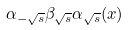<formula> <loc_0><loc_0><loc_500><loc_500>\alpha _ { - \sqrt { s } } \beta _ { \sqrt { s } } \alpha _ { \sqrt { s } } ( x )</formula> 